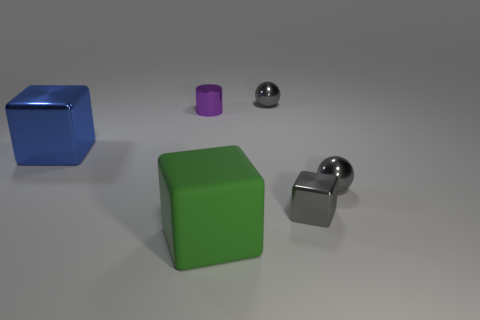Are there any other things that have the same material as the big green thing?
Your response must be concise. No. Is there any other thing that is the same shape as the tiny purple metal object?
Your response must be concise. No. Are there an equal number of small cylinders in front of the large green cube and gray balls?
Give a very brief answer. No. What number of blue things have the same material as the large blue cube?
Ensure brevity in your answer.  0. There is a cylinder that is the same material as the tiny gray cube; what is its color?
Provide a succinct answer. Purple. Is the shape of the matte object the same as the tiny purple metallic object?
Offer a terse response. No. Is there a large metallic object that is behind the gray thing behind the small metal sphere right of the small block?
Keep it short and to the point. No. What number of small metal things are the same color as the small cube?
Ensure brevity in your answer.  2. The shiny thing that is the same size as the matte object is what shape?
Your response must be concise. Cube. There is a blue metal block; are there any green cubes in front of it?
Your response must be concise. Yes. 